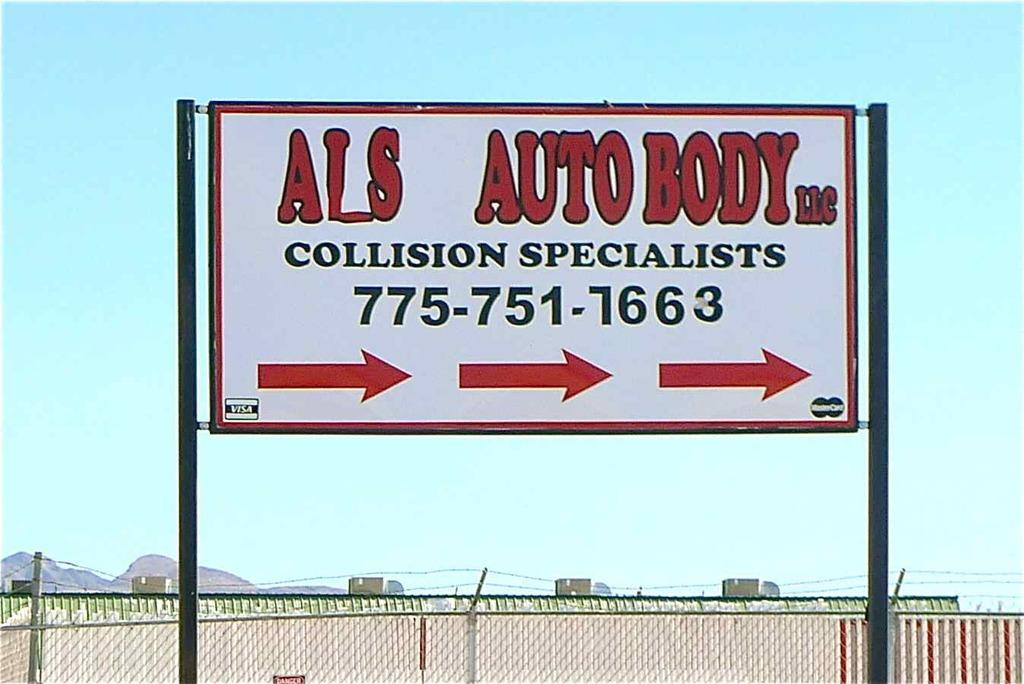<image>
Write a terse but informative summary of the picture. ALS Auto Body, collision specialists is shown on this billboard. 